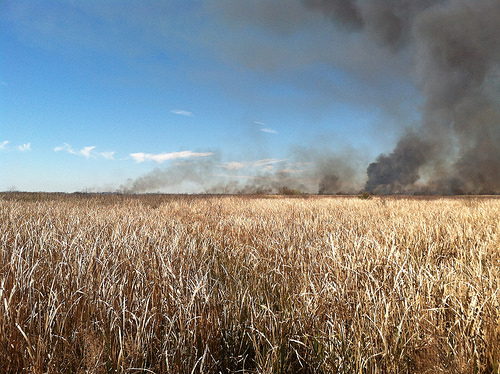<image>
Can you confirm if the smoke is in the sky? Yes. The smoke is contained within or inside the sky, showing a containment relationship. 